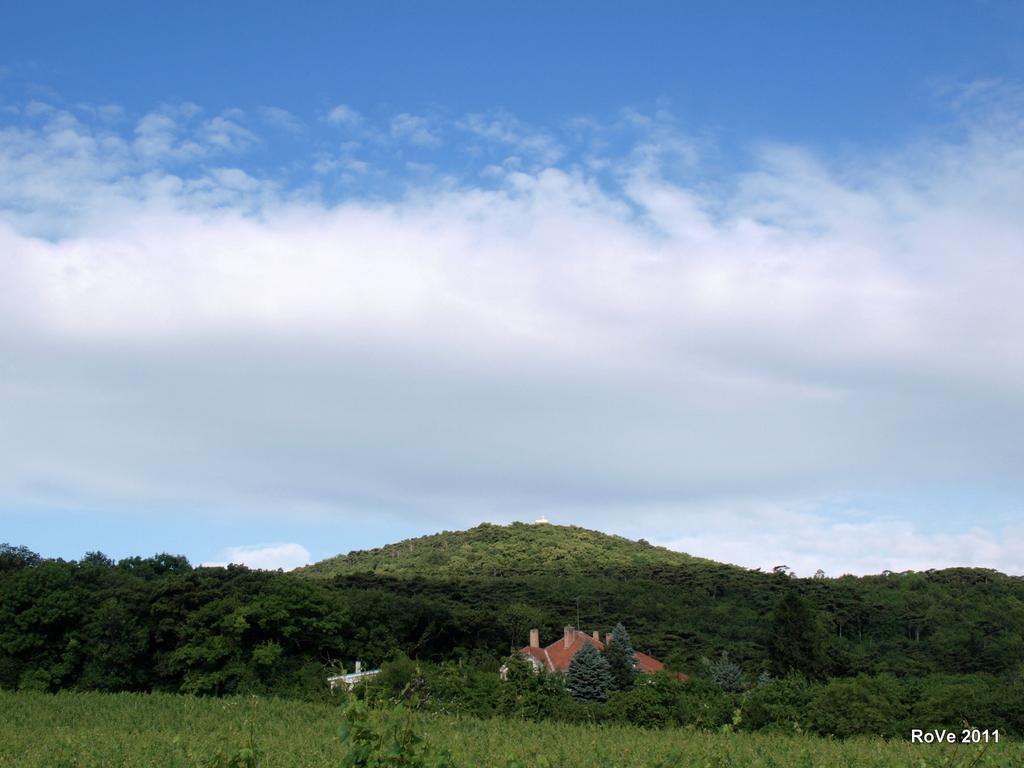How would you summarize this image in a sentence or two? In this image in the front there's grass on the ground and in the background there are trees and the sky is cloudy. 